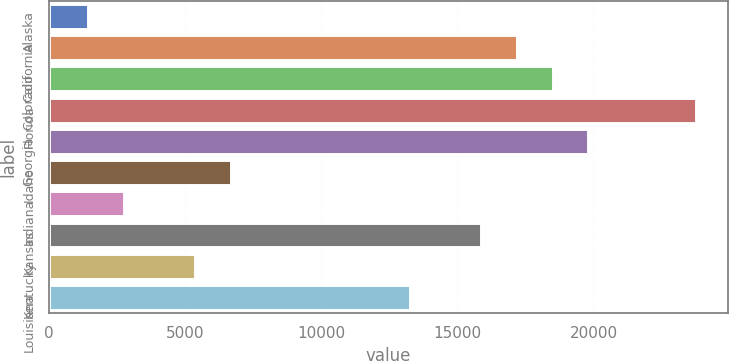<chart> <loc_0><loc_0><loc_500><loc_500><bar_chart><fcel>Alaska<fcel>California<fcel>Colorado<fcel>Florida<fcel>Georgia<fcel>Idaho<fcel>Indiana<fcel>Kansas<fcel>Kentucky<fcel>Louisiana<nl><fcel>1442.2<fcel>17188.6<fcel>18500.8<fcel>23749.6<fcel>19813<fcel>6691<fcel>2754.4<fcel>15876.4<fcel>5378.8<fcel>13252<nl></chart> 